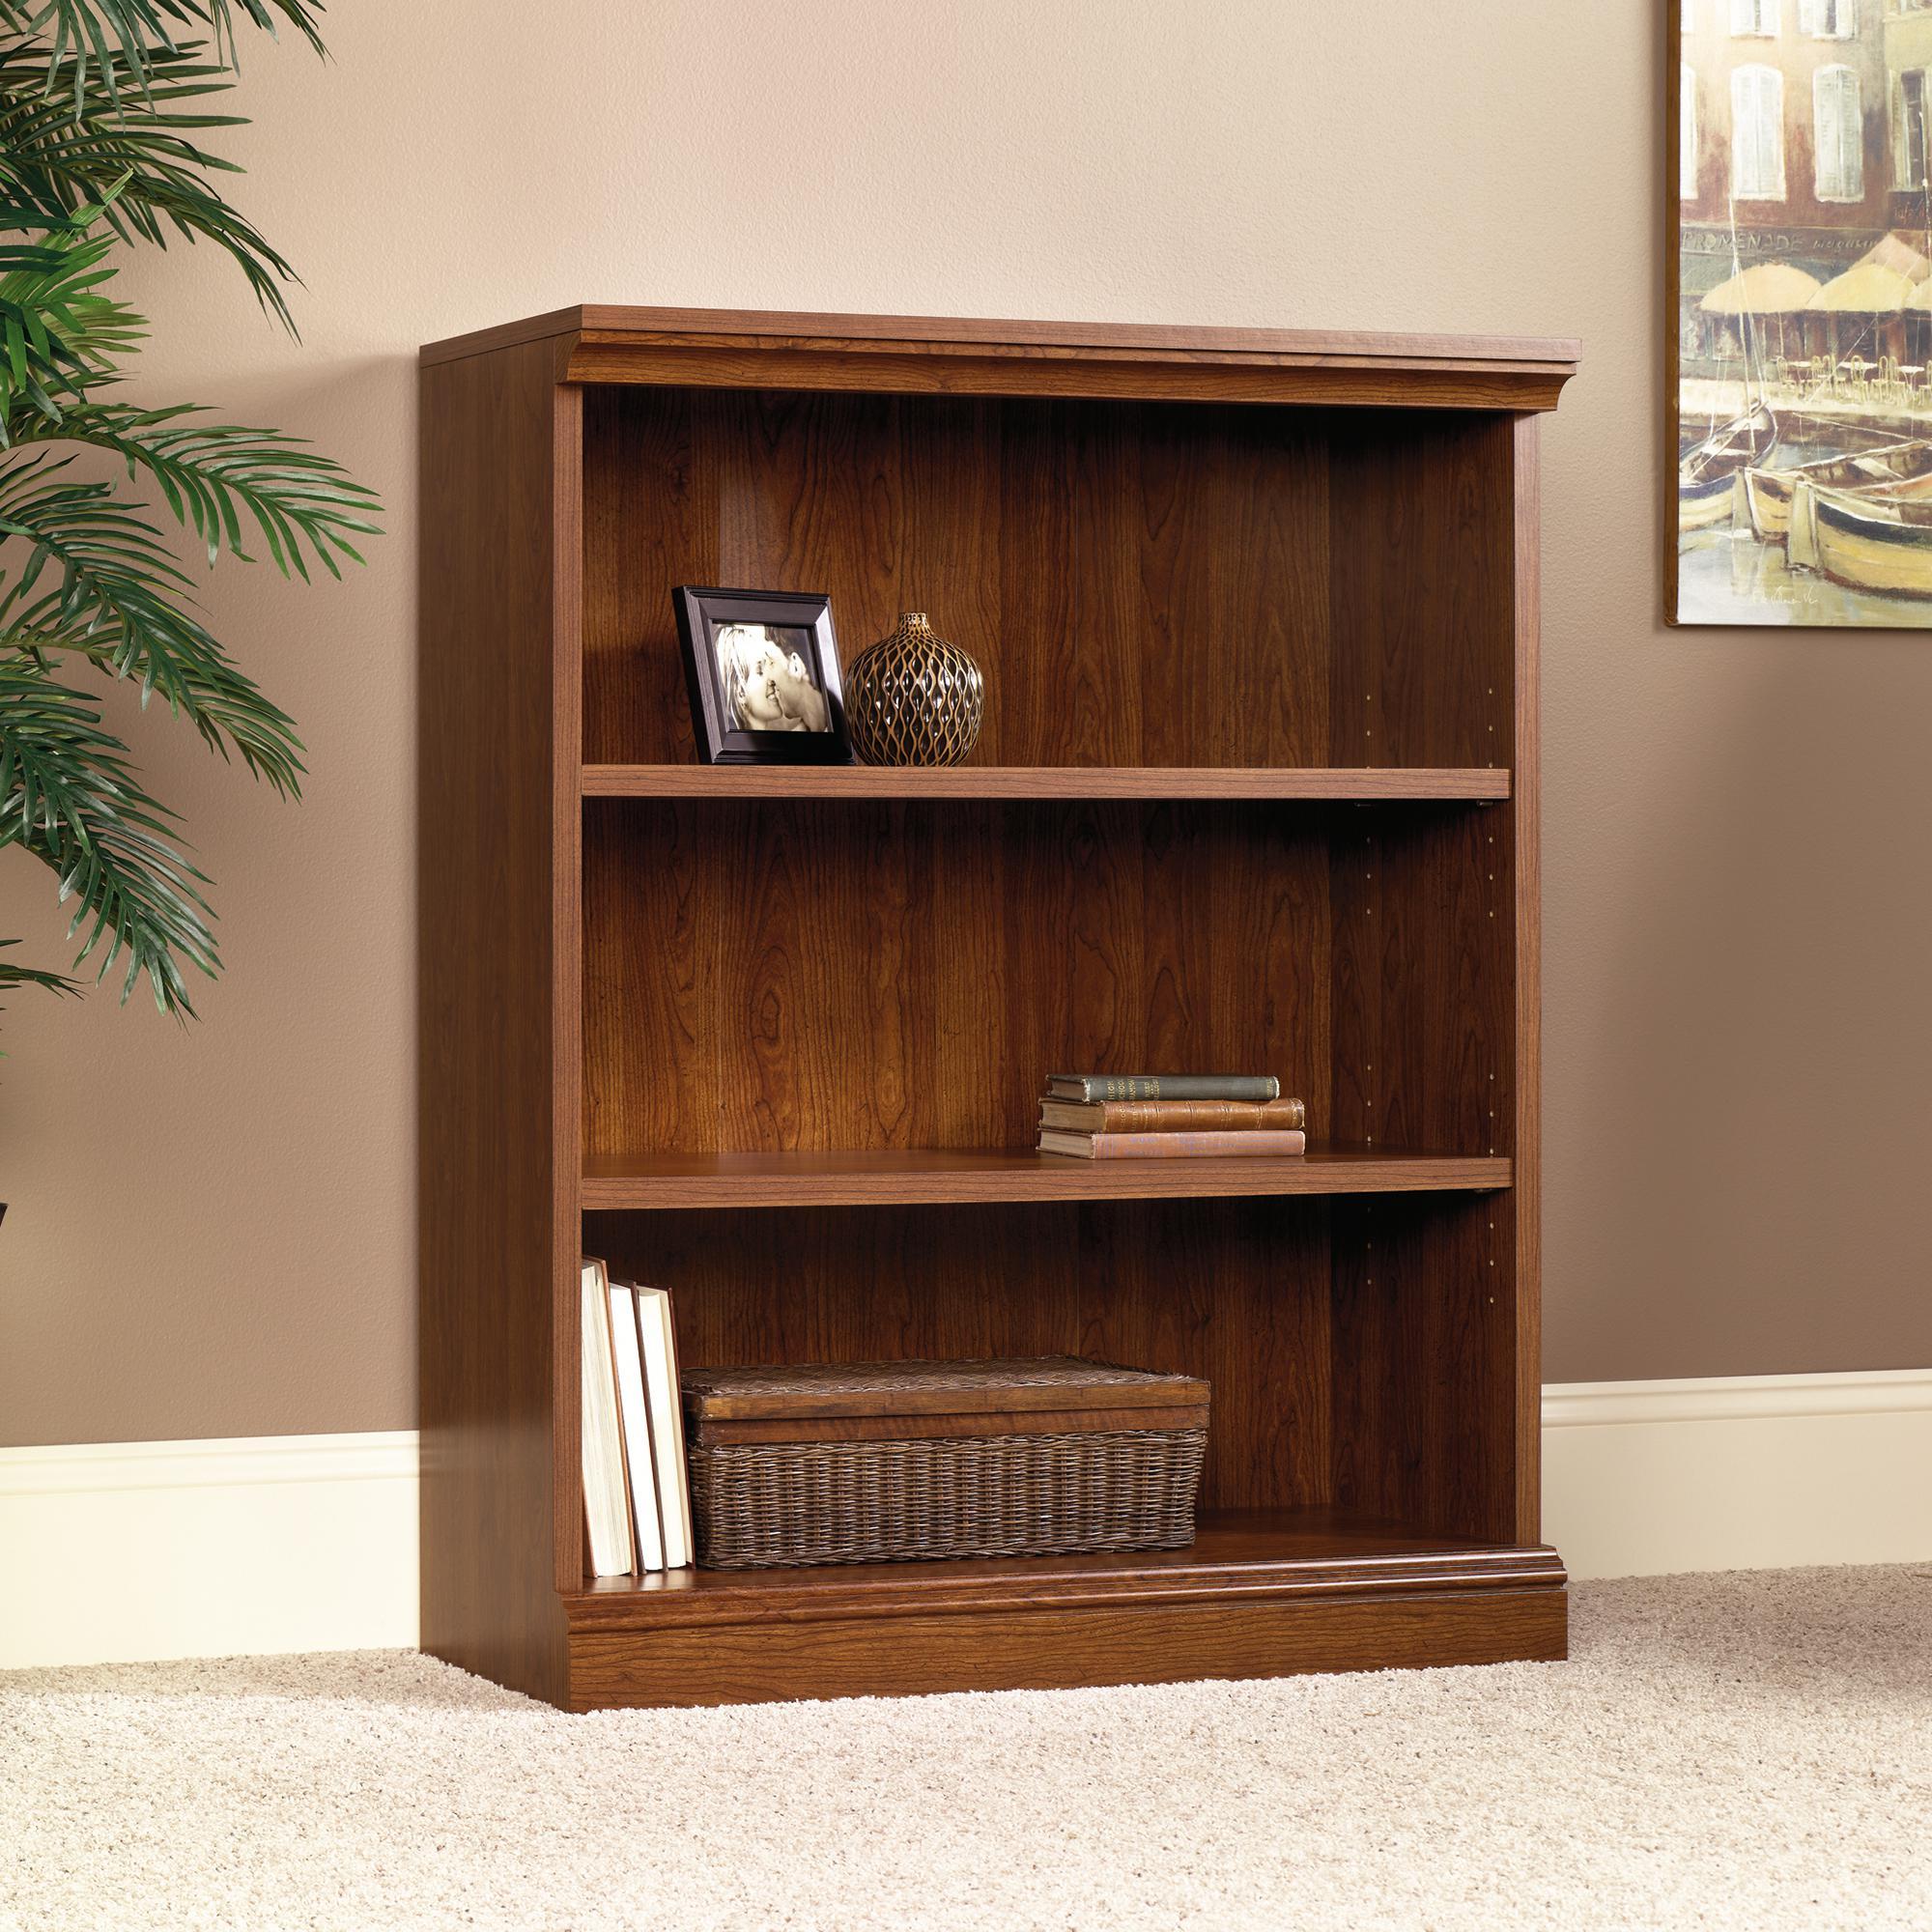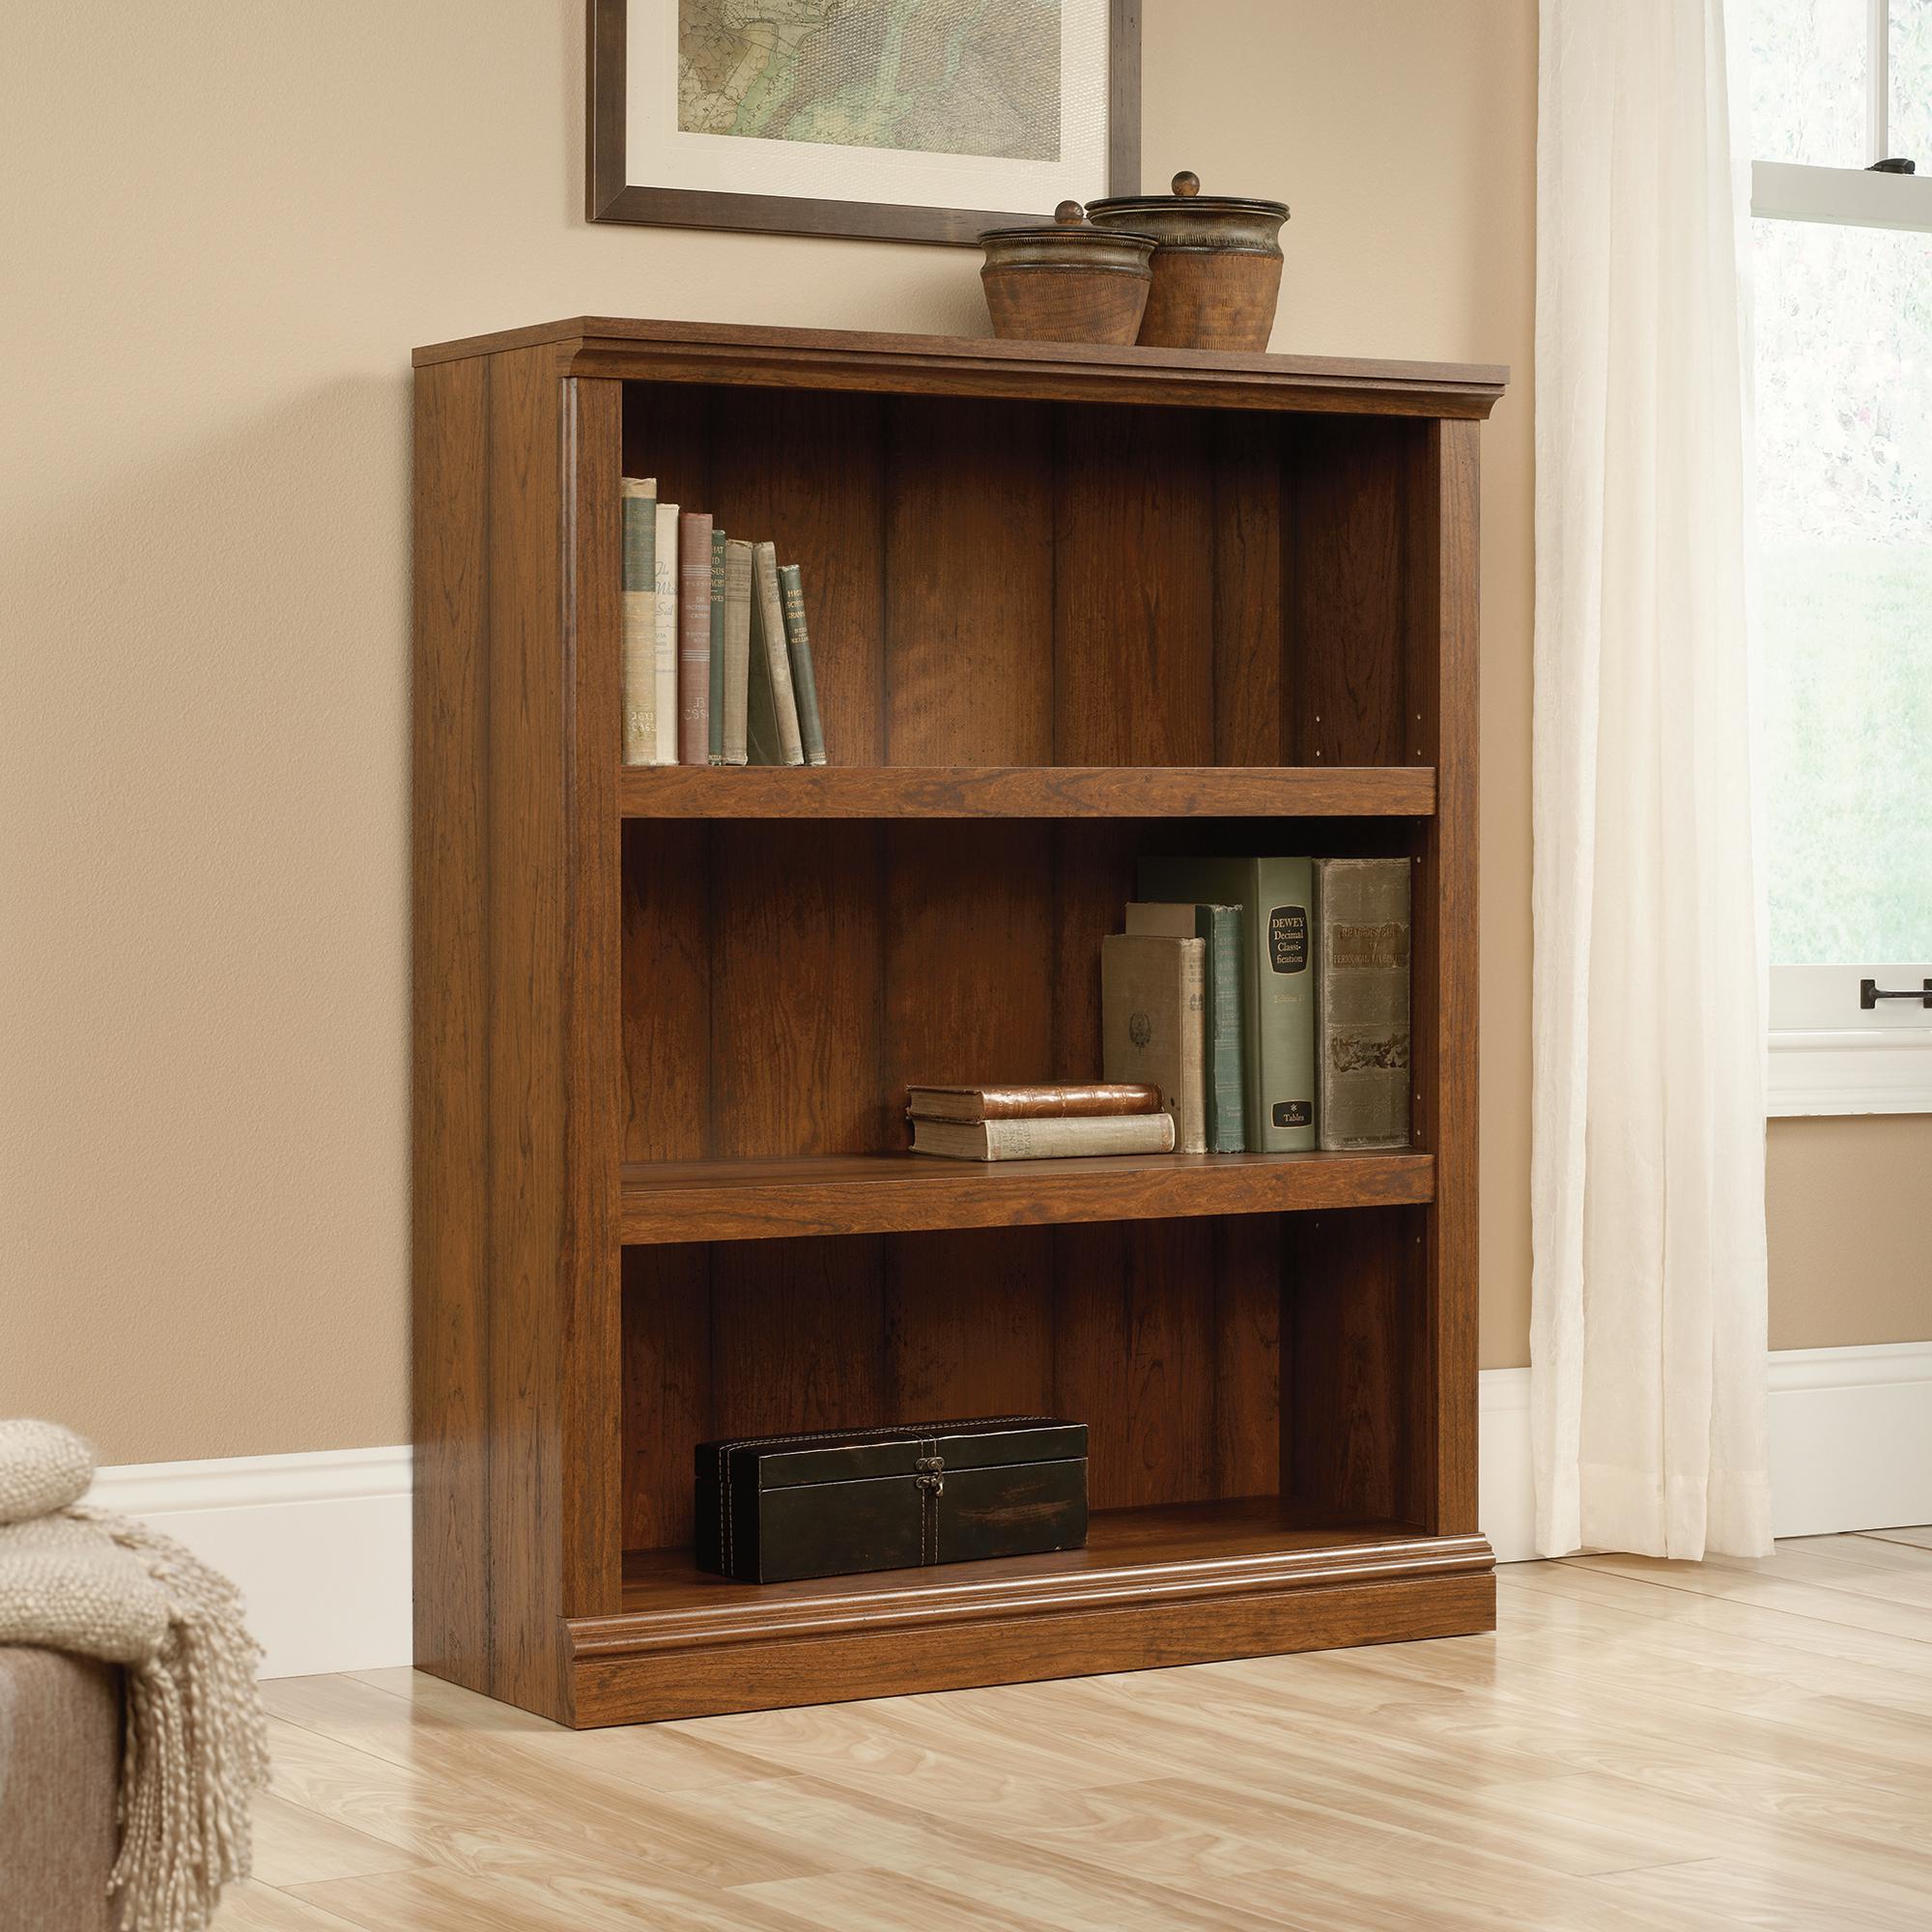The first image is the image on the left, the second image is the image on the right. For the images displayed, is the sentence "Each bookcase has a solid back and exactly three shelves, and one bookcase has two items side-by-side on its top, while the other has an empty top." factually correct? Answer yes or no. Yes. The first image is the image on the left, the second image is the image on the right. Given the left and right images, does the statement "Both bookcases have three shelves." hold true? Answer yes or no. Yes. 